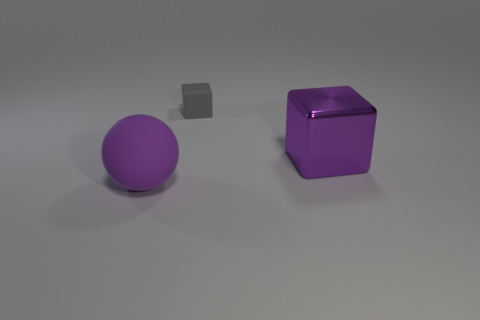Add 1 red matte cubes. How many objects exist? 4 Subtract all spheres. How many objects are left? 2 Subtract 0 brown cubes. How many objects are left? 3 Subtract all small gray blocks. Subtract all tiny blue matte cylinders. How many objects are left? 2 Add 3 purple metallic cubes. How many purple metallic cubes are left? 4 Add 3 large metal cylinders. How many large metal cylinders exist? 3 